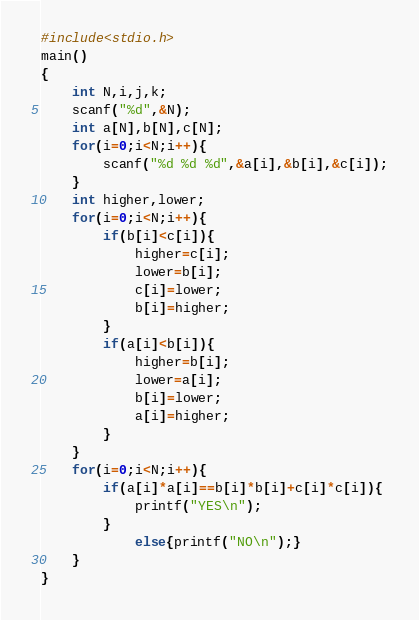<code> <loc_0><loc_0><loc_500><loc_500><_C_>#include<stdio.h>
main()
{
	int N,i,j,k;
	scanf("%d",&N);
	int a[N],b[N],c[N];
	for(i=0;i<N;i++){
		scanf("%d %d %d",&a[i],&b[i],&c[i]);
	}
	int higher,lower;
	for(i=0;i<N;i++){
		if(b[i]<c[i]){
			higher=c[i];
			lower=b[i];
			c[i]=lower;
			b[i]=higher;
		}
		if(a[i]<b[i]){
			higher=b[i];
			lower=a[i];
			b[i]=lower;
			a[i]=higher;
		}
	}
	for(i=0;i<N;i++){
		if(a[i]*a[i]==b[i]*b[i]+c[i]*c[i]){
			printf("YES\n");
		}
			else{printf("NO\n");}
	}
}</code> 